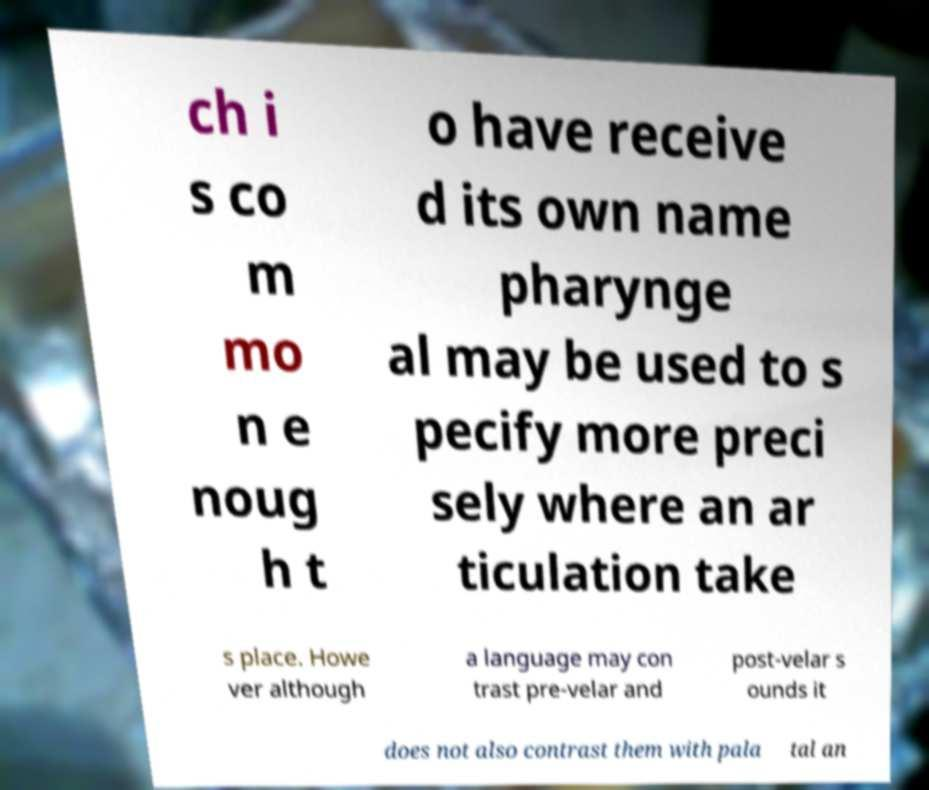Please identify and transcribe the text found in this image. ch i s co m mo n e noug h t o have receive d its own name pharynge al may be used to s pecify more preci sely where an ar ticulation take s place. Howe ver although a language may con trast pre-velar and post-velar s ounds it does not also contrast them with pala tal an 